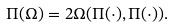Convert formula to latex. <formula><loc_0><loc_0><loc_500><loc_500>\Pi ( \Omega ) = 2 \Omega ( \Pi ( \cdot ) , \Pi ( \cdot ) ) .</formula> 